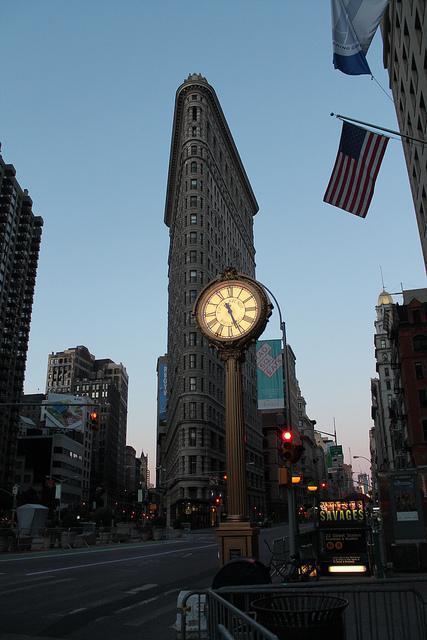How many clocks are there?
Give a very brief answer. 1. 